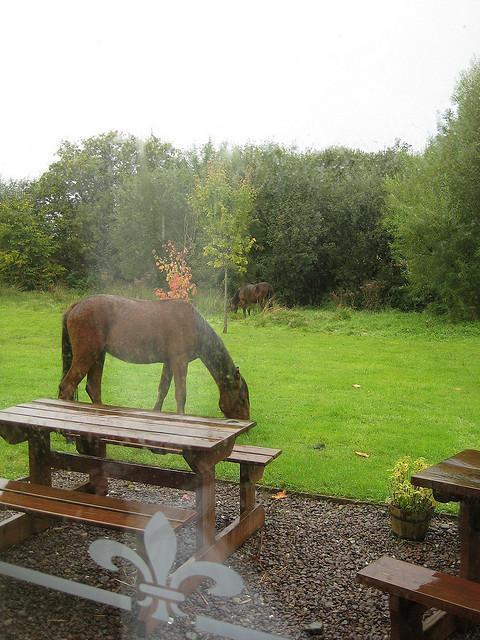How many animals in this photo?
Give a very brief answer. 2. How many dining tables are there?
Give a very brief answer. 2. How many benches can you see?
Give a very brief answer. 3. 